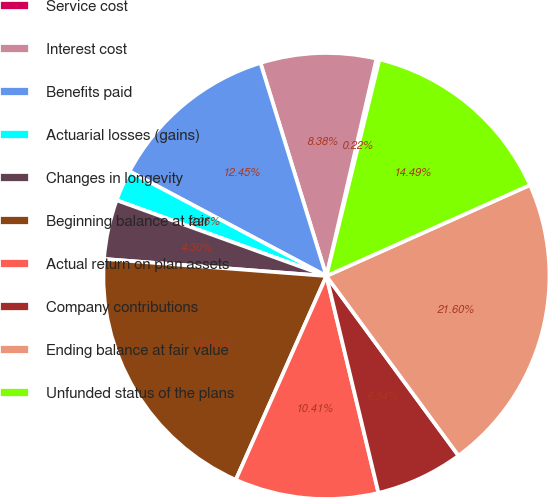Convert chart. <chart><loc_0><loc_0><loc_500><loc_500><pie_chart><fcel>Service cost<fcel>Interest cost<fcel>Benefits paid<fcel>Actuarial losses (gains)<fcel>Changes in longevity<fcel>Beginning balance at fair<fcel>Actual return on plan assets<fcel>Company contributions<fcel>Ending balance at fair value<fcel>Unfunded status of the plans<nl><fcel>0.22%<fcel>8.38%<fcel>12.45%<fcel>2.26%<fcel>4.3%<fcel>19.56%<fcel>10.41%<fcel>6.34%<fcel>21.6%<fcel>14.49%<nl></chart> 